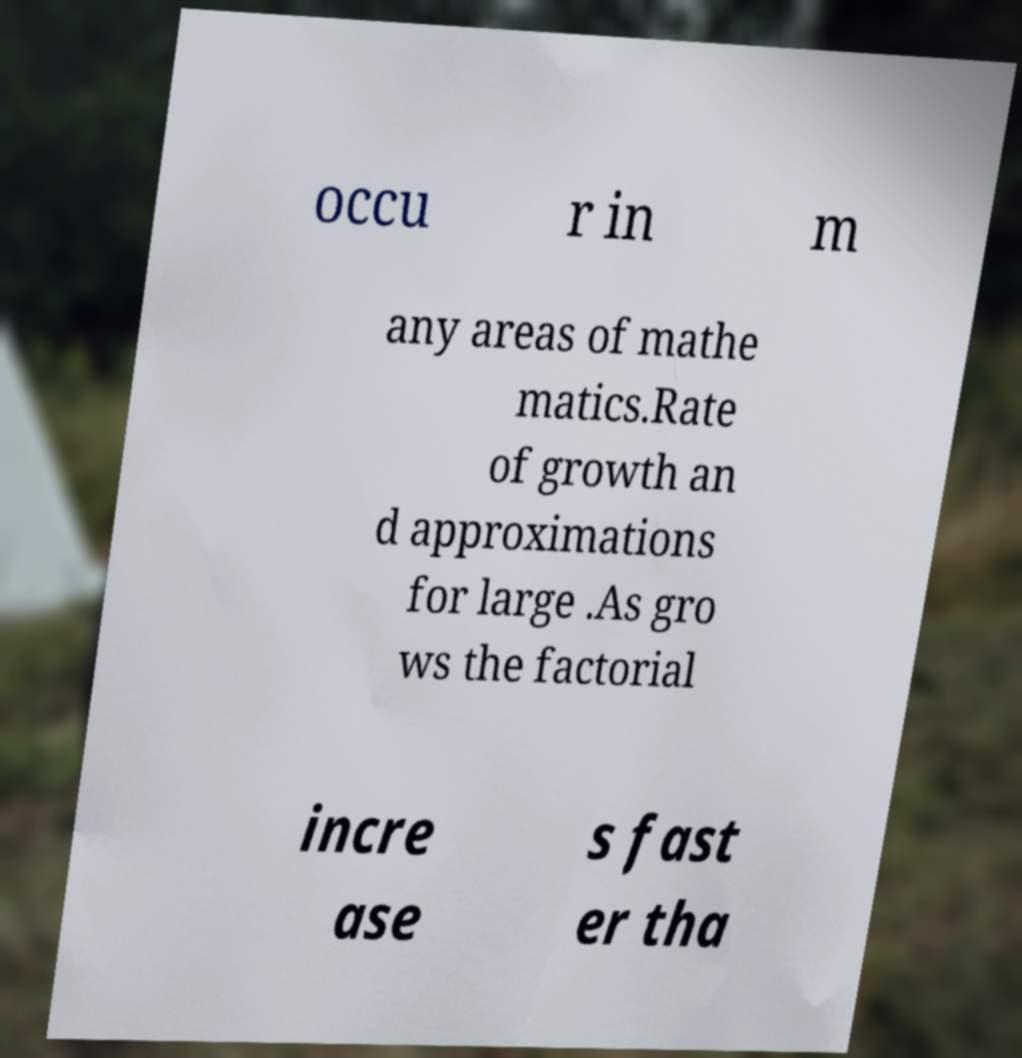What messages or text are displayed in this image? I need them in a readable, typed format. occu r in m any areas of mathe matics.Rate of growth an d approximations for large .As gro ws the factorial incre ase s fast er tha 